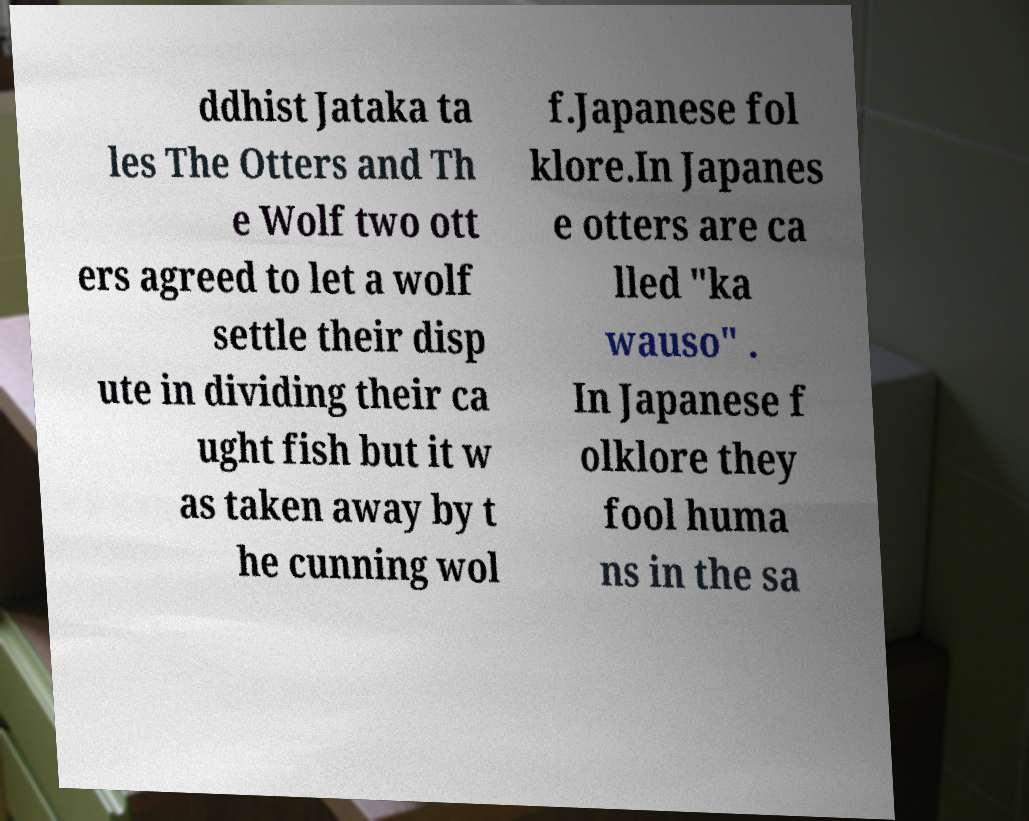Could you assist in decoding the text presented in this image and type it out clearly? ddhist Jataka ta les The Otters and Th e Wolf two ott ers agreed to let a wolf settle their disp ute in dividing their ca ught fish but it w as taken away by t he cunning wol f.Japanese fol klore.In Japanes e otters are ca lled "ka wauso" . In Japanese f olklore they fool huma ns in the sa 